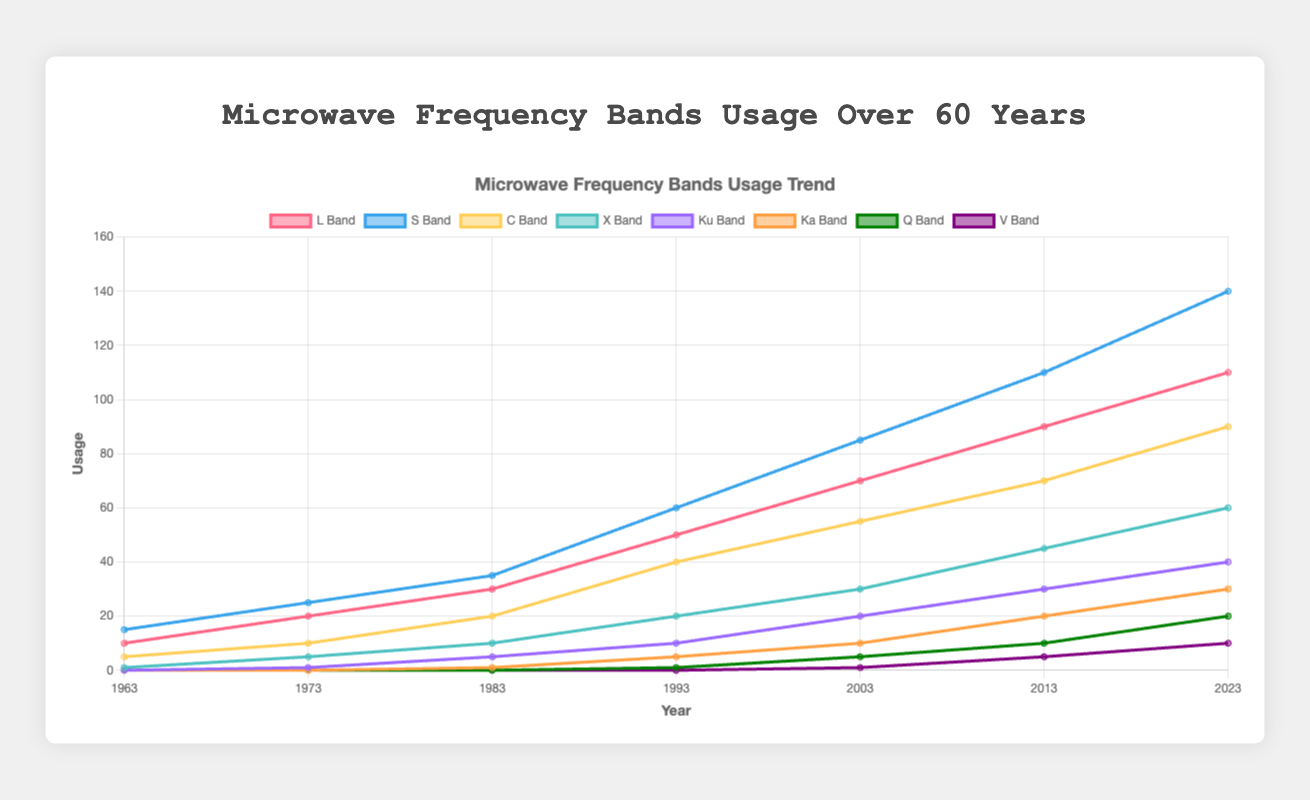What is the usage trend for the L Band from 1963 to 2023? To determine the usage trend for the L Band, examine the line corresponding to the L Band from 1963 to 2023. Notice that the data points gradually increase: 10, 20, 30, 50, 70, 90, 110, indicating a consistent upward trend in usage.
Answer: Upward trend How does the usage of the C Band in 1983 compare to its usage in 2023? First, find the value for the C Band in 1983, which is 20. Then, find the value for 2023, which is 90. The C Band usage has increased from 20 to 90, which means it has more than quadrupled.
Answer: Increased significantly By how much did the usage of the S Band increase between 1993 and 2023? Locate the S Band values for the years 1993 and 2023. For 1993, the usage is 60, and for 2023, it’s 140. Calculate the difference: 140 - 60 = 80.
Answer: 80 Which frequency band shows the earliest rise in usage? Identify the non-zero values for each band starting from the earliest year. L Band and S Band have non-zero values starting from 1963, while other bands start later. Hence, L Band and S Band show the earliest rise.
Answer: L Band and S Band What can you infer about the Ka Band usage between 1963 and 1983? The Ka Band shows values of 0 for 1963, 1973, and 1983. It means that there was no usage for the Ka Band during this period.
Answer: No usage By how much did the Q Band usage increase from 1993 to 2003? Identify the Q Band values for the years 1993 and 2003. For 1993, it is 1, and for 2003, it is 5. Calculate the difference: 5 - 1 = 4.
Answer: 4 In 2023, which frequency band has the second-highest usage? Scan the 2023 values across all bands. The values are: L Band: 110, S Band: 140, C Band: 90, X Band: 60, Ku Band: 40, Ka Band: 30, Q Band: 20, V Band: 10. The highest is S Band with 140 and the second-highest is L Band with 110.
Answer: L Band What is the overall average usage of the Ku Band from 1963 to 2023? Collect the Ku Band values for each year: 0, 1, 5, 10, 20, 30, 40. Sum these values: 0 + 1 + 5 + 10 + 20 + 30 + 40 = 106. Divide the sum by the number of years (7): 106 / 7 ≈ 15.14.
Answer: ~15.14 